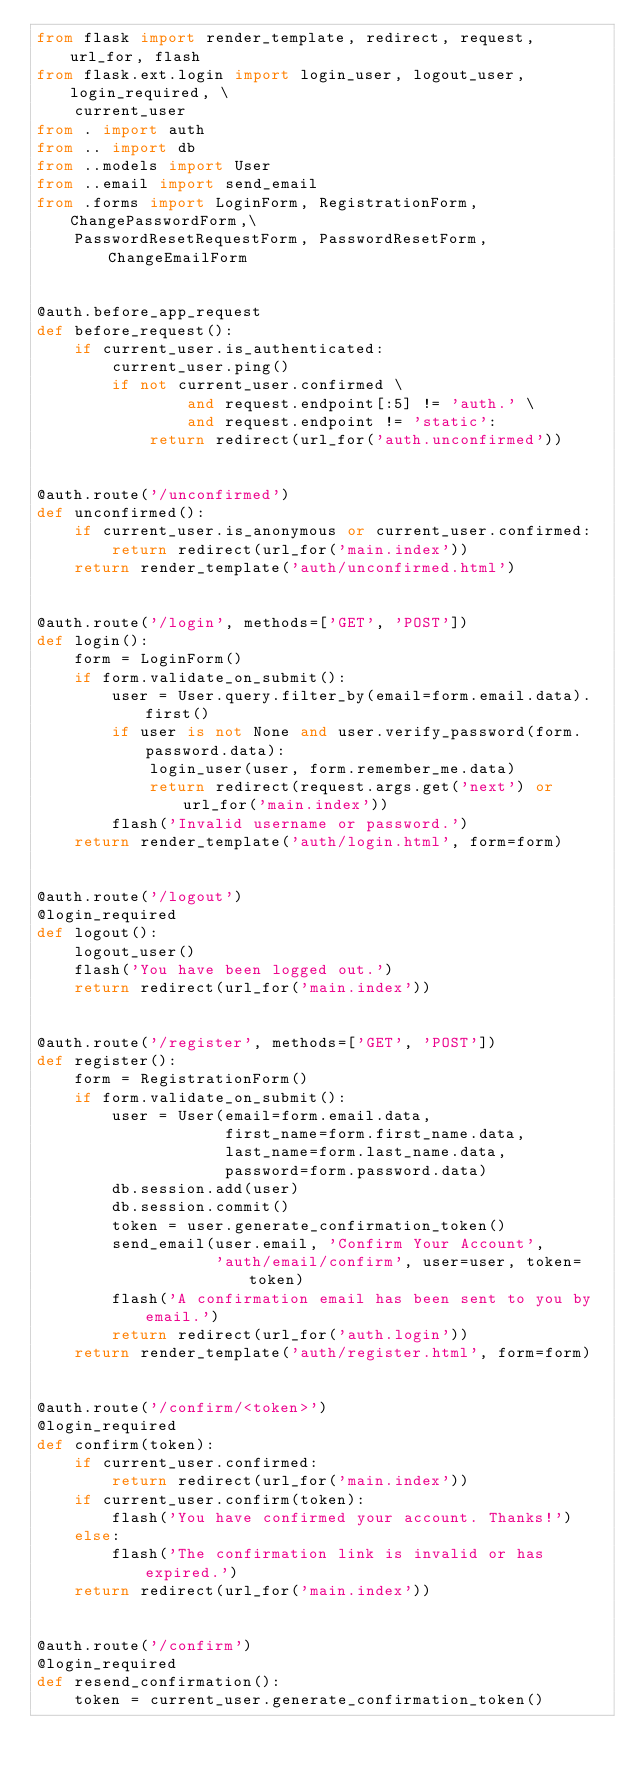Convert code to text. <code><loc_0><loc_0><loc_500><loc_500><_Python_>from flask import render_template, redirect, request, url_for, flash
from flask.ext.login import login_user, logout_user, login_required, \
    current_user
from . import auth
from .. import db
from ..models import User
from ..email import send_email
from .forms import LoginForm, RegistrationForm, ChangePasswordForm,\
    PasswordResetRequestForm, PasswordResetForm, ChangeEmailForm


@auth.before_app_request
def before_request():
    if current_user.is_authenticated:
        current_user.ping()
        if not current_user.confirmed \
                and request.endpoint[:5] != 'auth.' \
                and request.endpoint != 'static':
            return redirect(url_for('auth.unconfirmed'))


@auth.route('/unconfirmed')
def unconfirmed():
    if current_user.is_anonymous or current_user.confirmed:
        return redirect(url_for('main.index'))
    return render_template('auth/unconfirmed.html')


@auth.route('/login', methods=['GET', 'POST'])
def login():
    form = LoginForm()
    if form.validate_on_submit():
        user = User.query.filter_by(email=form.email.data).first()
        if user is not None and user.verify_password(form.password.data):
            login_user(user, form.remember_me.data)
            return redirect(request.args.get('next') or url_for('main.index'))
        flash('Invalid username or password.')
    return render_template('auth/login.html', form=form)


@auth.route('/logout')
@login_required
def logout():
    logout_user()
    flash('You have been logged out.')
    return redirect(url_for('main.index'))


@auth.route('/register', methods=['GET', 'POST'])
def register():
    form = RegistrationForm()
    if form.validate_on_submit():
        user = User(email=form.email.data,
                    first_name=form.first_name.data,
                    last_name=form.last_name.data,
                    password=form.password.data)
        db.session.add(user)
        db.session.commit()
        token = user.generate_confirmation_token()
        send_email(user.email, 'Confirm Your Account',
                   'auth/email/confirm', user=user, token=token)
        flash('A confirmation email has been sent to you by email.')
        return redirect(url_for('auth.login'))
    return render_template('auth/register.html', form=form)


@auth.route('/confirm/<token>')
@login_required
def confirm(token):
    if current_user.confirmed:
        return redirect(url_for('main.index'))
    if current_user.confirm(token):
        flash('You have confirmed your account. Thanks!')
    else:
        flash('The confirmation link is invalid or has expired.')
    return redirect(url_for('main.index'))


@auth.route('/confirm')
@login_required
def resend_confirmation():
    token = current_user.generate_confirmation_token()</code> 